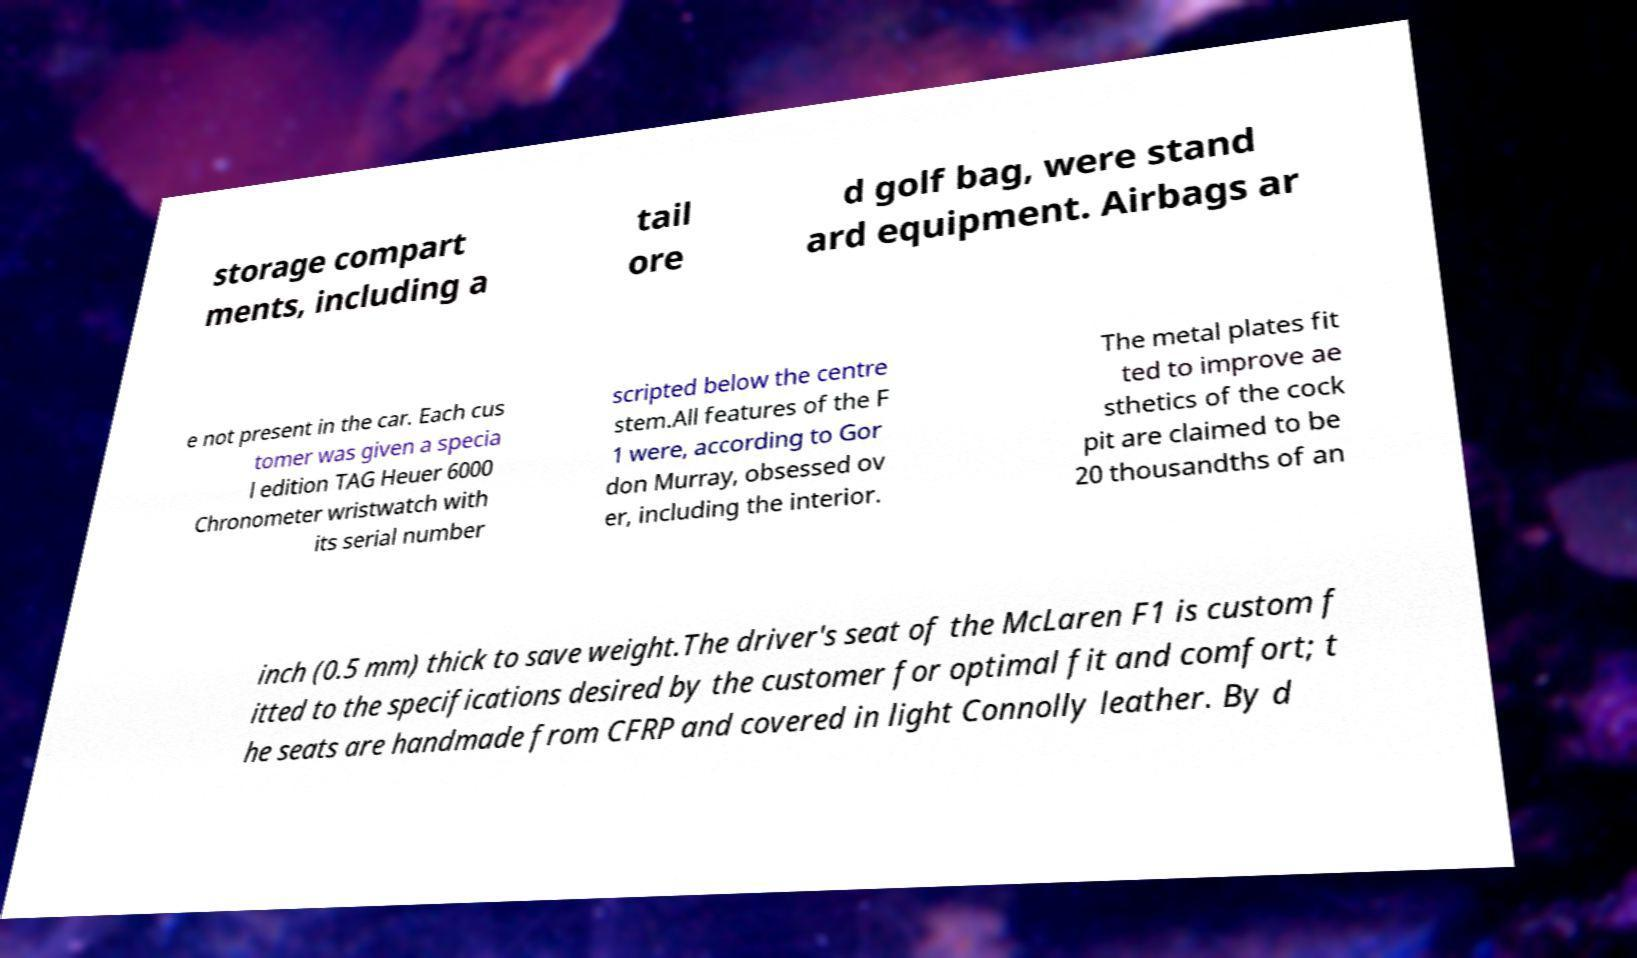Please read and relay the text visible in this image. What does it say? storage compart ments, including a tail ore d golf bag, were stand ard equipment. Airbags ar e not present in the car. Each cus tomer was given a specia l edition TAG Heuer 6000 Chronometer wristwatch with its serial number scripted below the centre stem.All features of the F 1 were, according to Gor don Murray, obsessed ov er, including the interior. The metal plates fit ted to improve ae sthetics of the cock pit are claimed to be 20 thousandths of an inch (0.5 mm) thick to save weight.The driver's seat of the McLaren F1 is custom f itted to the specifications desired by the customer for optimal fit and comfort; t he seats are handmade from CFRP and covered in light Connolly leather. By d 